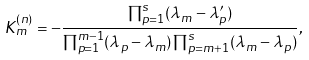Convert formula to latex. <formula><loc_0><loc_0><loc_500><loc_500>K _ { m } ^ { ( n ) } = - \frac { \prod _ { p = 1 } ^ { s } ( \lambda _ { m } - \lambda ^ { \prime } _ { p } ) } { \prod _ { p = 1 } ^ { m - 1 } ( \lambda _ { p } - \lambda _ { m } ) \prod _ { p = m + 1 } ^ { s } ( \lambda _ { m } - \lambda _ { p } ) } ,</formula> 